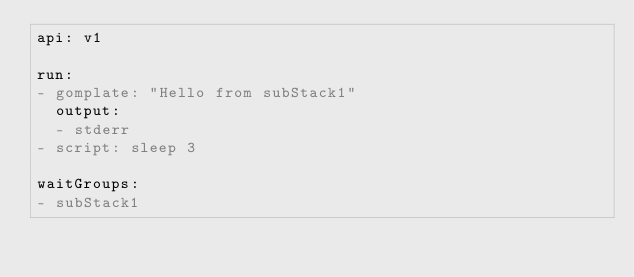<code> <loc_0><loc_0><loc_500><loc_500><_YAML_>api: v1

run:
- gomplate: "Hello from subStack1"
  output:
  - stderr
- script: sleep 3

waitGroups:
- subStack1
</code> 